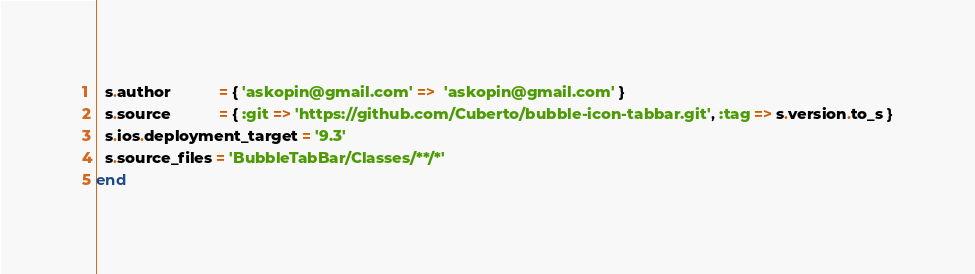<code> <loc_0><loc_0><loc_500><loc_500><_Ruby_>  s.author           = { 'askopin@gmail.com' =>  'askopin@gmail.com' }
  s.source           = { :git => 'https://github.com/Cuberto/bubble-icon-tabbar.git', :tag => s.version.to_s }
  s.ios.deployment_target = '9.3'
  s.source_files = 'BubbleTabBar/Classes/**/*'
end
</code> 